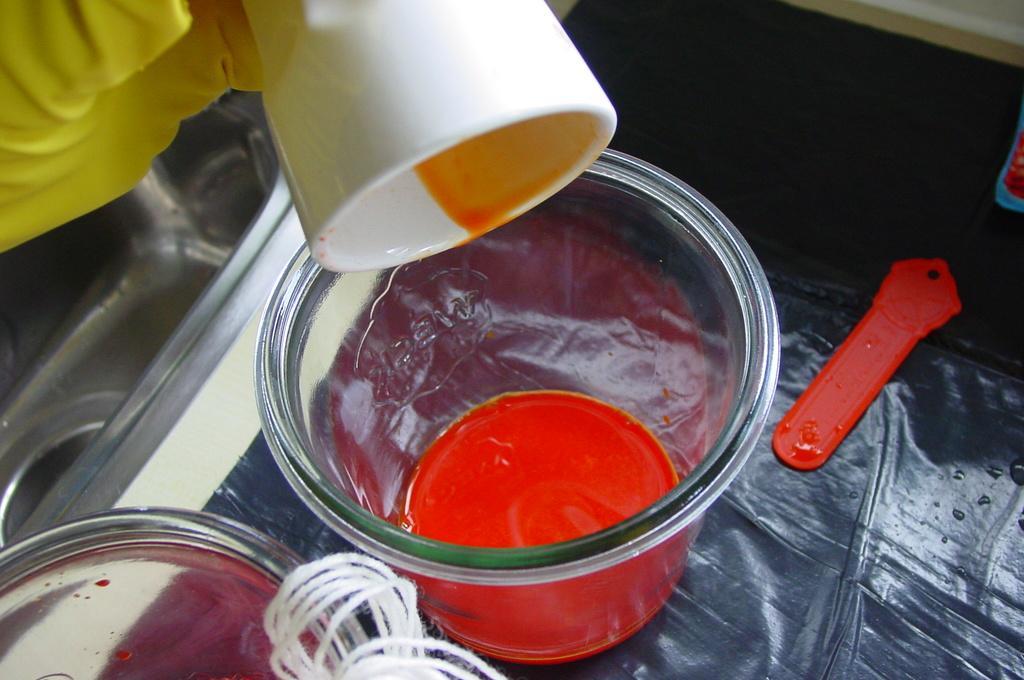Could you give a brief overview of what you see in this image? In this image we can see bowls. There is a white color cup and there are some other objects on the surface. 